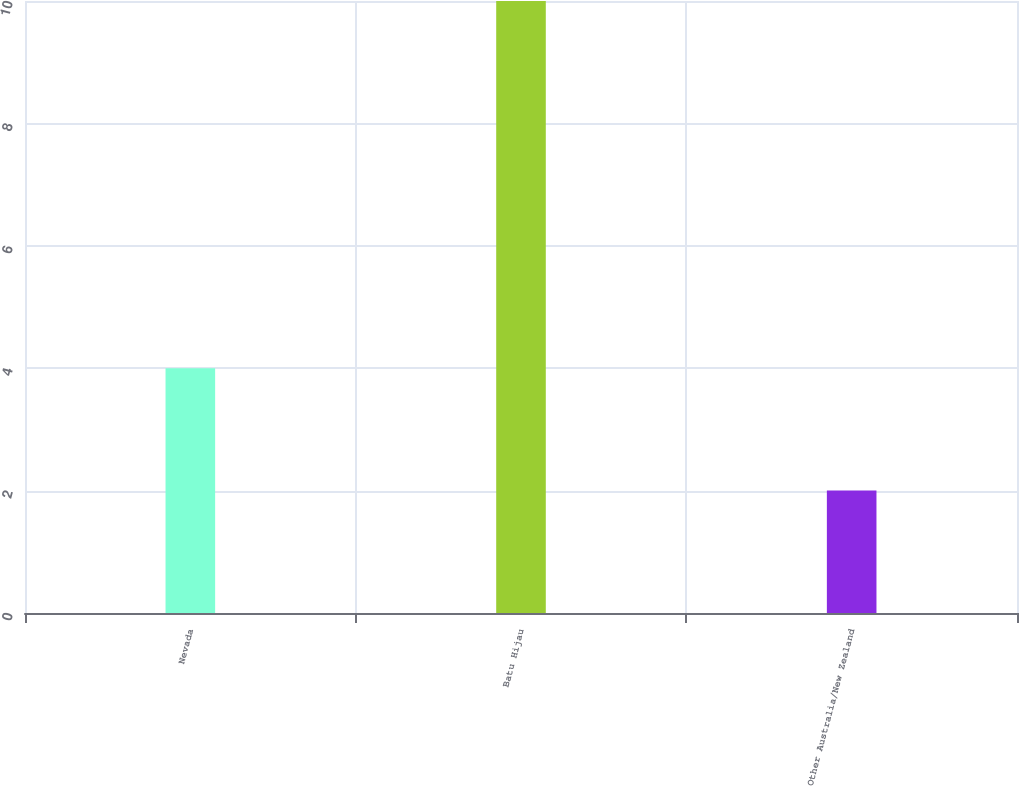<chart> <loc_0><loc_0><loc_500><loc_500><bar_chart><fcel>Nevada<fcel>Batu Hijau<fcel>Other Australia/New Zealand<nl><fcel>4<fcel>10<fcel>2<nl></chart> 